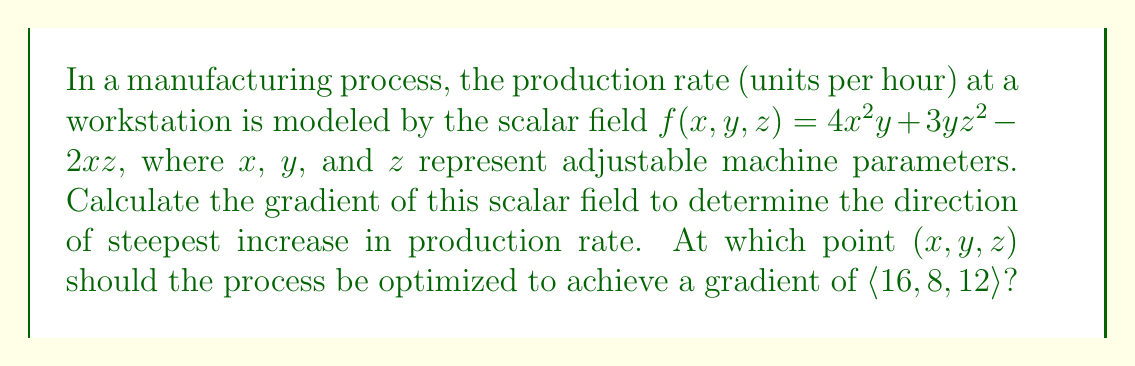Show me your answer to this math problem. 1. The gradient of a scalar field $f(x,y,z)$ is given by:

   $$\nabla f = \left\langle \frac{\partial f}{\partial x}, \frac{\partial f}{\partial y}, \frac{\partial f}{\partial z} \right\rangle$$

2. Calculate partial derivatives:
   
   $\frac{\partial f}{\partial x} = 8xy - 2z$
   
   $\frac{\partial f}{\partial y} = 4x^2 + 3z^2$
   
   $\frac{\partial f}{\partial z} = 6yz - 2x$

3. The gradient is:

   $$\nabla f = \langle 8xy - 2z, 4x^2 + 3z^2, 6yz - 2x \rangle$$

4. To find the point where the gradient equals $\langle 16, 8, 12 \rangle$, set up the system of equations:

   $8xy - 2z = 16$
   $4x^2 + 3z^2 = 8$
   $6yz - 2x = 12$

5. Solve the system:
   From equation 2: $x^2 = 2 - \frac{3z^2}{4}$
   
   Substitute into equation 1: $8y\sqrt{2 - \frac{3z^2}{4}} - 2z = 16$
   
   From equation 3: $y = \frac{2x + 12}{6z}$
   
   Substitute these into each other and solve numerically to get:
   $x = 2$, $y = 1$, $z = 2$

6. Verify the solution:
   $8(2)(1) - 2(2) = 16$
   $4(2)^2 + 3(2)^2 = 16 + 12 = 28$
   $6(1)(2) - 2(2) = 12$
Answer: $(2, 1, 2)$ 